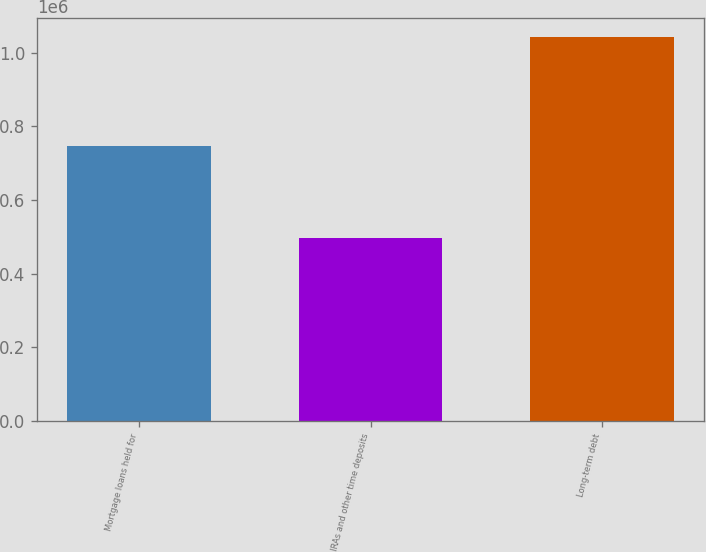Convert chart to OTSL. <chart><loc_0><loc_0><loc_500><loc_500><bar_chart><fcel>Mortgage loans held for<fcel>IRAs and other time deposits<fcel>Long-term debt<nl><fcel>744899<fcel>495379<fcel>1.0409e+06<nl></chart> 